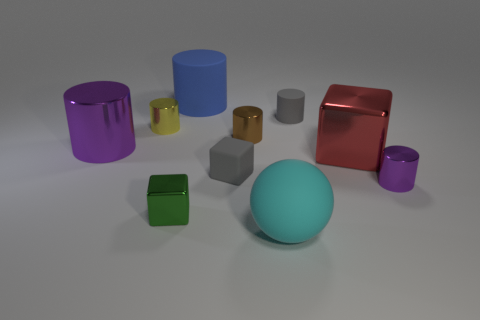Subtract all brown cylinders. How many cylinders are left? 5 Subtract all blue cylinders. How many cylinders are left? 5 Subtract 1 blocks. How many blocks are left? 2 Subtract all blue cubes. How many gray balls are left? 0 Subtract all yellow cubes. Subtract all red cylinders. How many cubes are left? 3 Subtract all brown cylinders. Subtract all shiny blocks. How many objects are left? 7 Add 9 green things. How many green things are left? 10 Add 7 small cyan cylinders. How many small cyan cylinders exist? 7 Subtract 1 gray cylinders. How many objects are left? 9 Subtract all blocks. How many objects are left? 7 